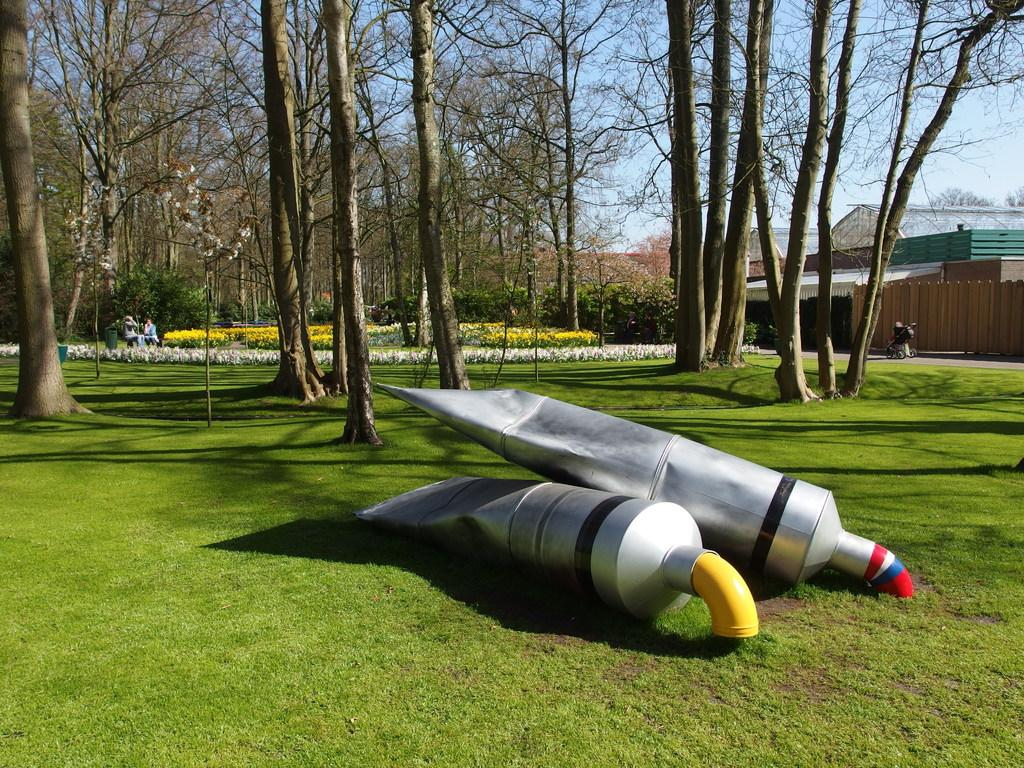What are the main objects in the center of the image? There are two big tubes in the center of the image. What can be seen in the background of the image? In the background of the image, there is sky, trees, buildings, plants, grass, flowers, and people. Can you describe the natural elements visible in the background? The natural elements in the background include trees, grass, plants, and flowers. What type of beetle can be seen crawling on the tubes in the image? There are no beetles present in the image; the main objects are the two big tubes. How does the end of the tubes affect the bit of information provided in the image? The end of the tubes does not affect the bit of information provided in the image, as there are no references to an end or bit in the given facts. 